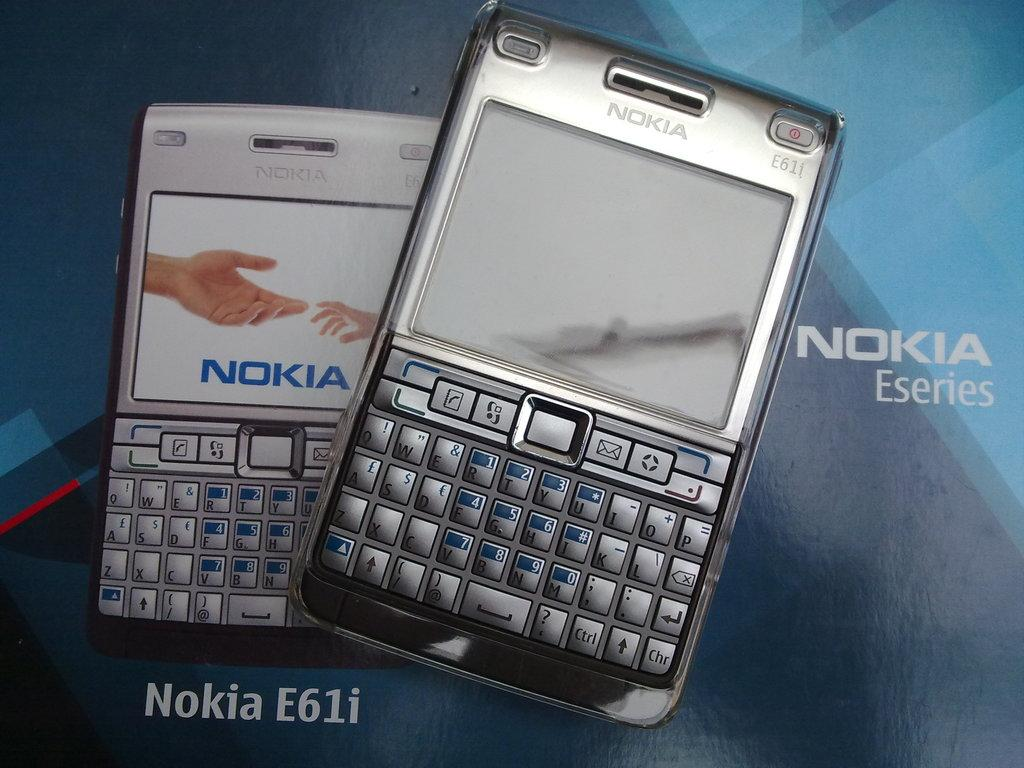Provide a one-sentence caption for the provided image. two nokia eseries e61i phones on blue background. 